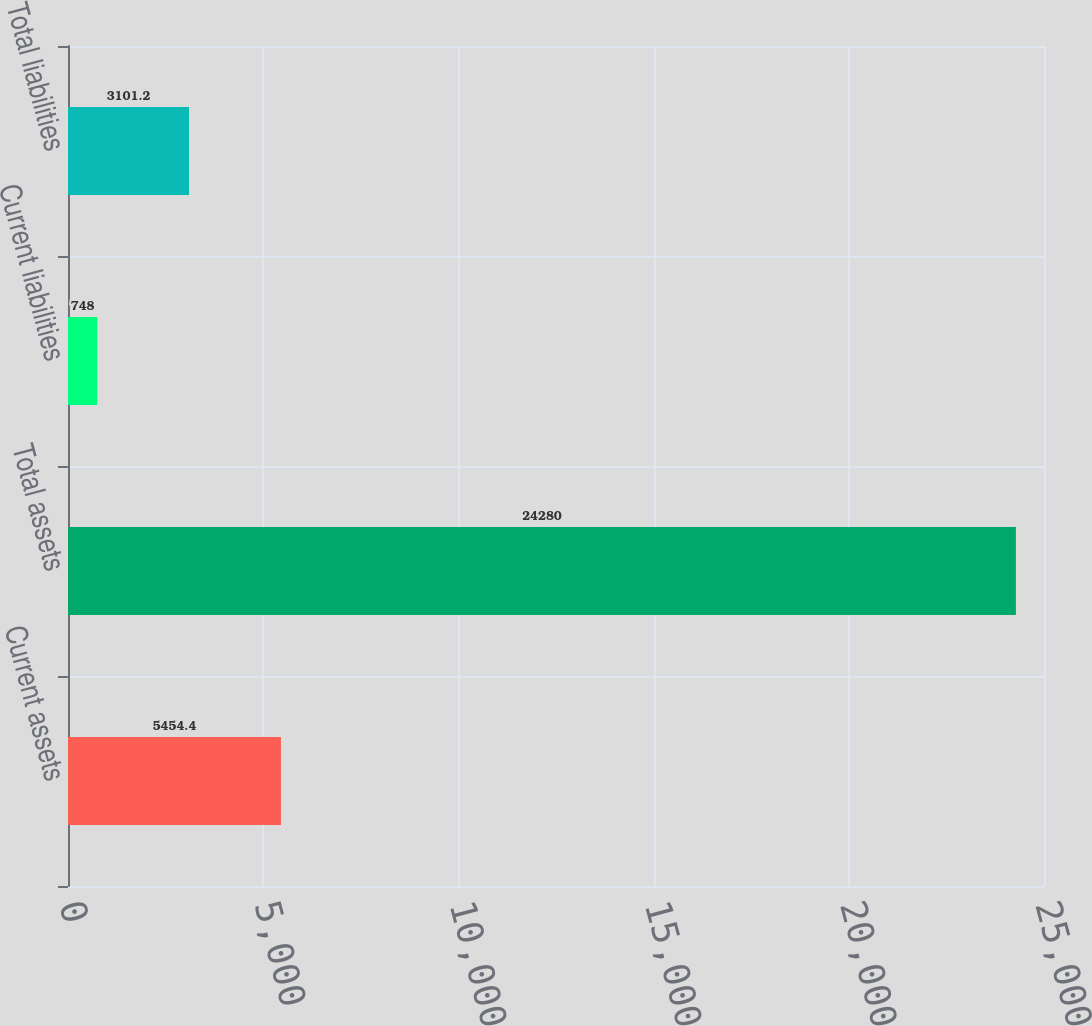<chart> <loc_0><loc_0><loc_500><loc_500><bar_chart><fcel>Current assets<fcel>Total assets<fcel>Current liabilities<fcel>Total liabilities<nl><fcel>5454.4<fcel>24280<fcel>748<fcel>3101.2<nl></chart> 